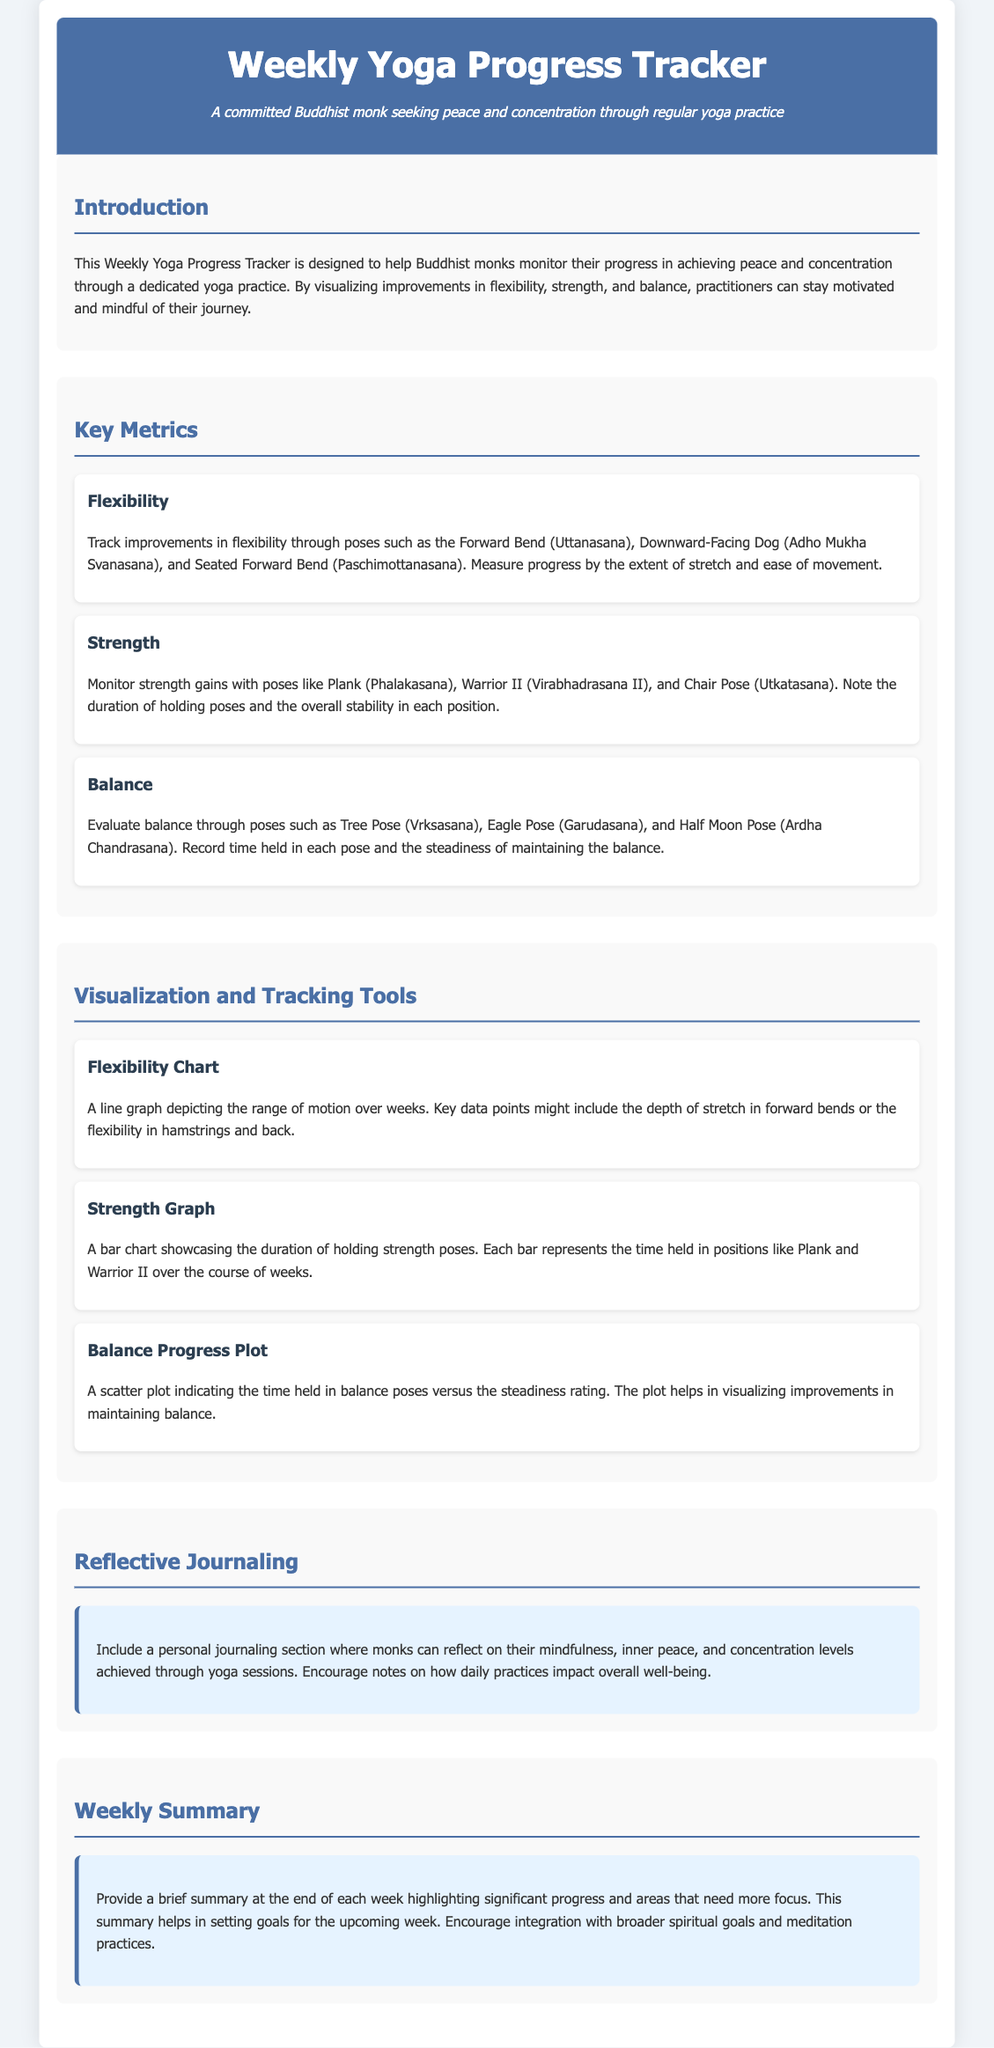What is the main purpose of the Weekly Yoga Progress Tracker? The purpose is to help Buddhist monks monitor their progress in achieving peace and concentration through yoga practice.
Answer: Monitor progress Which three key metrics are tracked in this document? The document specifies three key metrics: Flexibility, Strength, and Balance.
Answer: Flexibility, Strength, Balance What type of chart is used to depict range of motion improvements? A line graph is used for the Flexibility Chart to show range of motion over weeks.
Answer: Line graph What is the focus of the Reflective Journaling section? It encourages monks to reflect on mindfulness, inner peace, and concentration levels achieved through yoga.
Answer: Reflection on mindfulness How are strength gains monitored? Strength gains are monitored by the duration of holding poses and overall stability in each position.
Answer: Duration of holding poses What does the Weekly Summary highlight? It highlights significant progress and areas that need more focus for setting goals.
Answer: Significant progress and focus areas Which pose is associated with measuring balance improvements? The Tree Pose (Vrksasana) is one of the poses used to evaluate balance.
Answer: Tree Pose What does the Strength Graph showcase? The Strength Graph showcases the duration of holding strength poses over the weeks.
Answer: Duration of holding poses What is recorded in the Balance Progress Plot? The Balance Progress Plot records the time held in balance poses versus the steadiness rating.
Answer: Time and steadiness rating 